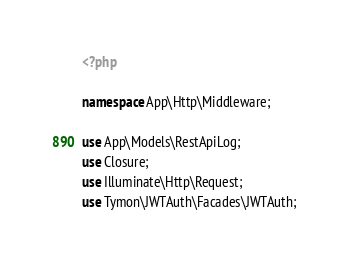Convert code to text. <code><loc_0><loc_0><loc_500><loc_500><_PHP_><?php

namespace App\Http\Middleware;

use App\Models\RestApiLog;
use Closure;
use Illuminate\Http\Request;
use Tymon\JWTAuth\Facades\JWTAuth;
</code> 